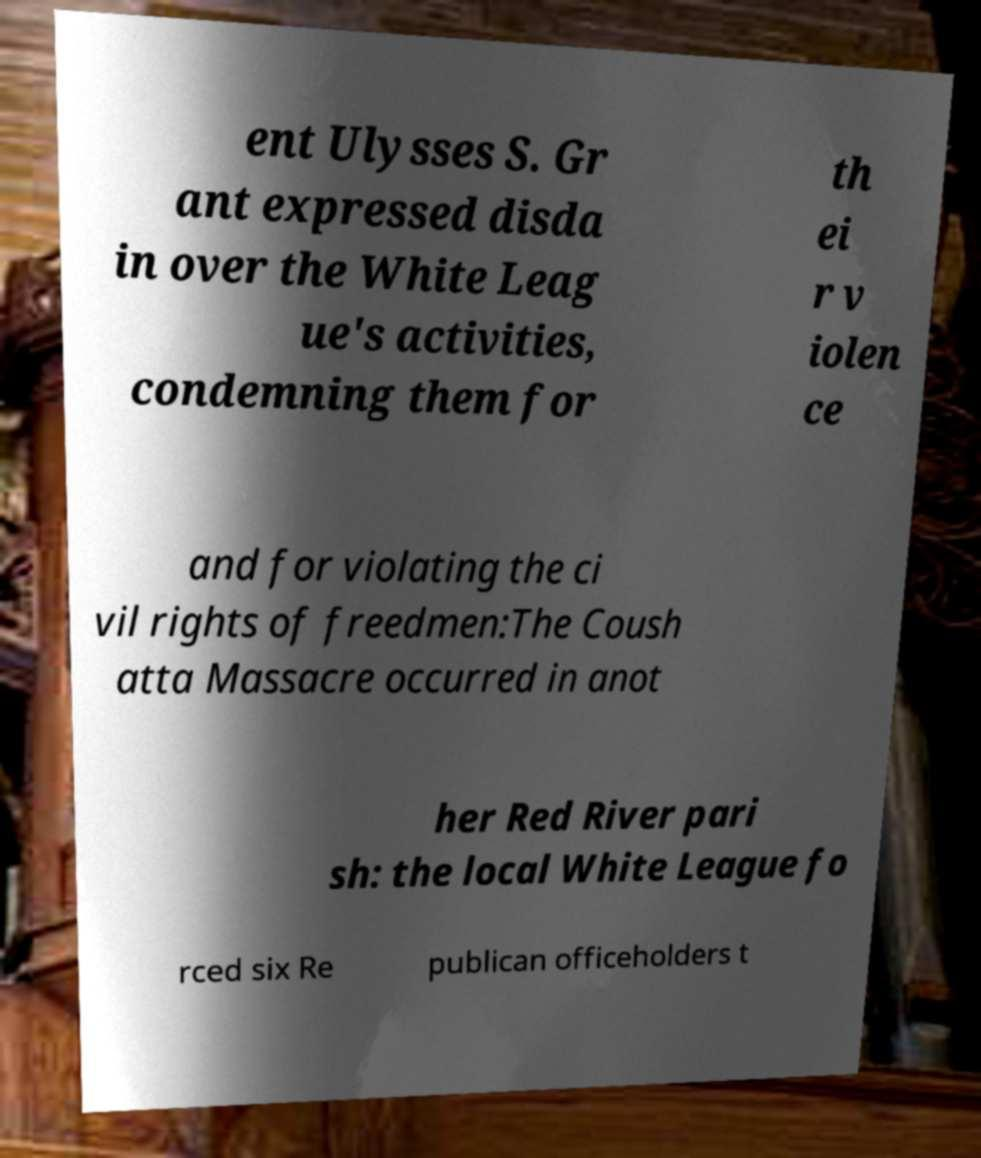Could you extract and type out the text from this image? ent Ulysses S. Gr ant expressed disda in over the White Leag ue's activities, condemning them for th ei r v iolen ce and for violating the ci vil rights of freedmen:The Coush atta Massacre occurred in anot her Red River pari sh: the local White League fo rced six Re publican officeholders t 